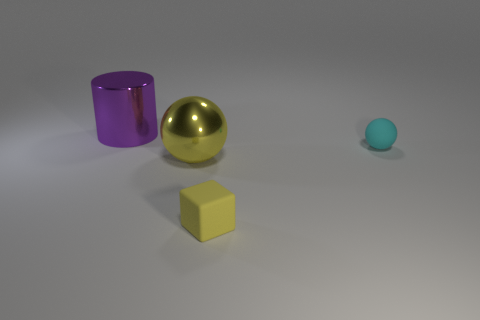Add 4 yellow matte objects. How many objects exist? 8 Add 2 yellow cubes. How many yellow cubes are left? 3 Add 3 large things. How many large things exist? 5 Subtract 0 cyan cylinders. How many objects are left? 4 Subtract all cylinders. How many objects are left? 3 Subtract all yellow cylinders. Subtract all blue cubes. How many cylinders are left? 1 Subtract all tiny cyan shiny cylinders. Subtract all large cylinders. How many objects are left? 3 